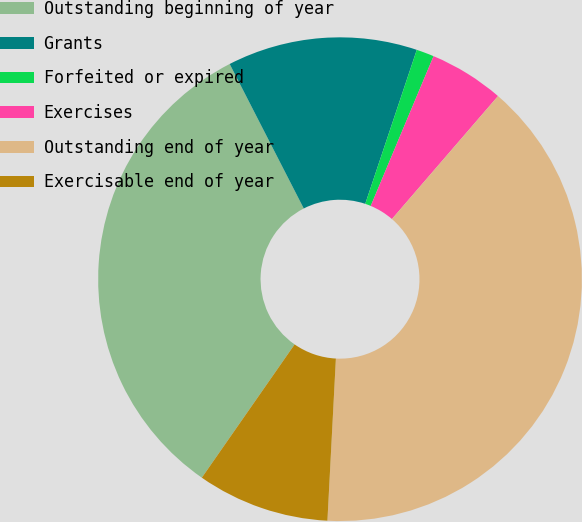Convert chart. <chart><loc_0><loc_0><loc_500><loc_500><pie_chart><fcel>Outstanding beginning of year<fcel>Grants<fcel>Forfeited or expired<fcel>Exercises<fcel>Outstanding end of year<fcel>Exercisable end of year<nl><fcel>32.78%<fcel>12.68%<fcel>1.18%<fcel>5.01%<fcel>39.5%<fcel>8.85%<nl></chart> 